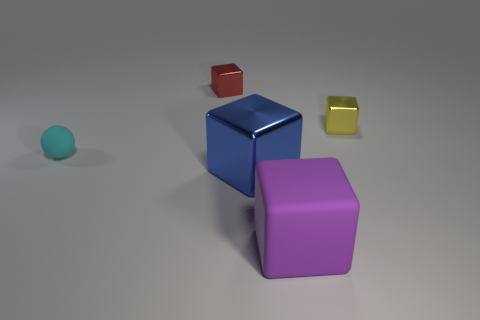There is a object that is both in front of the tiny yellow cube and behind the large blue metallic block; what is its shape?
Give a very brief answer. Sphere. The large thing left of the large rubber block has what shape?
Your answer should be compact. Cube. How many cubes are left of the small yellow shiny block and behind the tiny cyan matte thing?
Offer a very short reply. 1. There is a yellow shiny thing; is it the same size as the matte thing to the right of the small cyan matte object?
Provide a succinct answer. No. What is the size of the matte object that is to the right of the small block left of the metallic block in front of the tiny cyan matte ball?
Provide a succinct answer. Large. What is the size of the thing on the right side of the large purple rubber object?
Provide a short and direct response. Small. What shape is the big thing that is made of the same material as the red block?
Offer a terse response. Cube. Are the large thing behind the large purple matte block and the red thing made of the same material?
Your answer should be very brief. Yes. How many other things are the same material as the big blue block?
Ensure brevity in your answer.  2. What number of objects are either small things that are to the left of the yellow block or blocks in front of the blue block?
Ensure brevity in your answer.  3. 